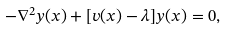Convert formula to latex. <formula><loc_0><loc_0><loc_500><loc_500>- \nabla ^ { 2 } y ( { x } ) + [ v ( { x } ) - \lambda ] y ( { x } ) = 0 ,</formula> 